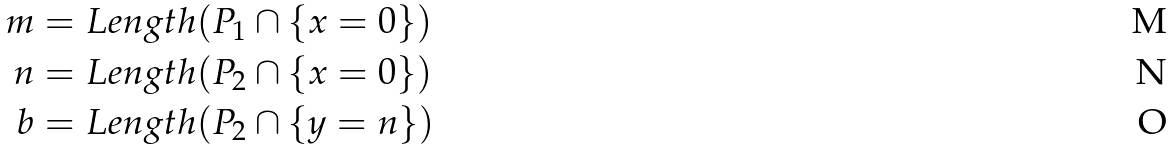<formula> <loc_0><loc_0><loc_500><loc_500>m & = L e n g t h ( P _ { 1 } \cap \{ x = 0 \} ) \\ n & = L e n g t h ( P _ { 2 } \cap \{ x = 0 \} ) \\ b & = L e n g t h ( P _ { 2 } \cap \{ y = n \} )</formula> 